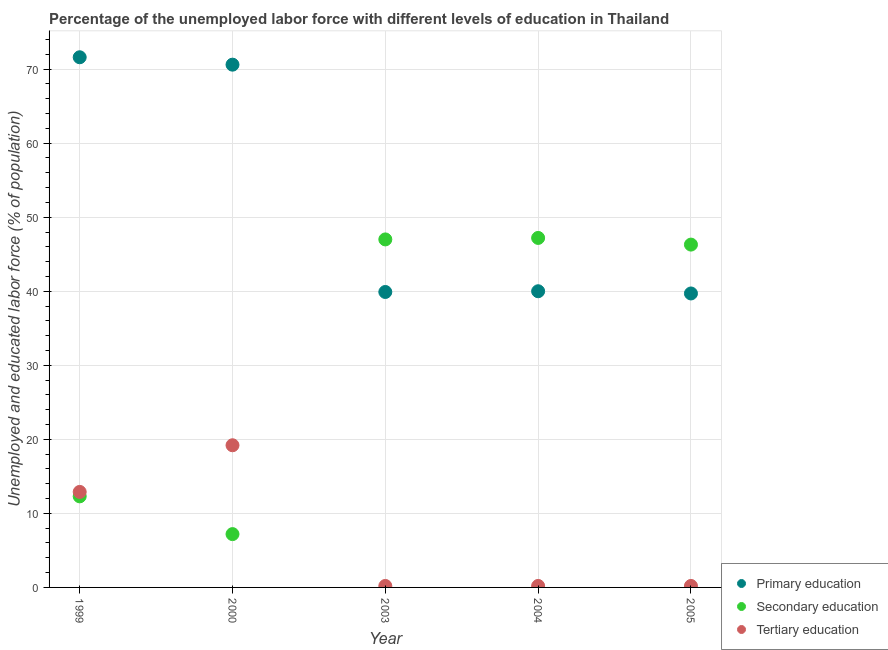How many different coloured dotlines are there?
Give a very brief answer. 3. What is the percentage of labor force who received primary education in 2005?
Offer a terse response. 39.7. Across all years, what is the maximum percentage of labor force who received secondary education?
Offer a terse response. 47.2. Across all years, what is the minimum percentage of labor force who received secondary education?
Keep it short and to the point. 7.2. What is the total percentage of labor force who received tertiary education in the graph?
Your response must be concise. 32.7. What is the difference between the percentage of labor force who received primary education in 2004 and that in 2005?
Your answer should be very brief. 0.3. What is the difference between the percentage of labor force who received secondary education in 2003 and the percentage of labor force who received tertiary education in 1999?
Your answer should be very brief. 34.1. What is the average percentage of labor force who received secondary education per year?
Provide a short and direct response. 32. In the year 2003, what is the difference between the percentage of labor force who received secondary education and percentage of labor force who received primary education?
Give a very brief answer. 7.1. In how many years, is the percentage of labor force who received secondary education greater than 58 %?
Ensure brevity in your answer.  0. What is the ratio of the percentage of labor force who received primary education in 1999 to that in 2005?
Offer a very short reply. 1.8. What is the difference between the highest and the second highest percentage of labor force who received tertiary education?
Provide a short and direct response. 6.3. What is the difference between the highest and the lowest percentage of labor force who received secondary education?
Your response must be concise. 40. In how many years, is the percentage of labor force who received tertiary education greater than the average percentage of labor force who received tertiary education taken over all years?
Your response must be concise. 2. Is the sum of the percentage of labor force who received primary education in 1999 and 2004 greater than the maximum percentage of labor force who received tertiary education across all years?
Offer a very short reply. Yes. Does the percentage of labor force who received secondary education monotonically increase over the years?
Provide a succinct answer. No. Is the percentage of labor force who received secondary education strictly greater than the percentage of labor force who received primary education over the years?
Ensure brevity in your answer.  No. How many years are there in the graph?
Give a very brief answer. 5. What is the difference between two consecutive major ticks on the Y-axis?
Offer a very short reply. 10. Does the graph contain any zero values?
Provide a succinct answer. No. Does the graph contain grids?
Provide a short and direct response. Yes. Where does the legend appear in the graph?
Make the answer very short. Bottom right. How are the legend labels stacked?
Provide a short and direct response. Vertical. What is the title of the graph?
Your answer should be very brief. Percentage of the unemployed labor force with different levels of education in Thailand. Does "Ages 15-64" appear as one of the legend labels in the graph?
Ensure brevity in your answer.  No. What is the label or title of the X-axis?
Make the answer very short. Year. What is the label or title of the Y-axis?
Give a very brief answer. Unemployed and educated labor force (% of population). What is the Unemployed and educated labor force (% of population) in Primary education in 1999?
Give a very brief answer. 71.6. What is the Unemployed and educated labor force (% of population) of Secondary education in 1999?
Keep it short and to the point. 12.3. What is the Unemployed and educated labor force (% of population) in Tertiary education in 1999?
Your response must be concise. 12.9. What is the Unemployed and educated labor force (% of population) in Primary education in 2000?
Provide a succinct answer. 70.6. What is the Unemployed and educated labor force (% of population) of Secondary education in 2000?
Offer a terse response. 7.2. What is the Unemployed and educated labor force (% of population) in Tertiary education in 2000?
Your answer should be compact. 19.2. What is the Unemployed and educated labor force (% of population) in Primary education in 2003?
Offer a terse response. 39.9. What is the Unemployed and educated labor force (% of population) in Tertiary education in 2003?
Offer a terse response. 0.2. What is the Unemployed and educated labor force (% of population) of Secondary education in 2004?
Provide a short and direct response. 47.2. What is the Unemployed and educated labor force (% of population) in Tertiary education in 2004?
Make the answer very short. 0.2. What is the Unemployed and educated labor force (% of population) in Primary education in 2005?
Ensure brevity in your answer.  39.7. What is the Unemployed and educated labor force (% of population) of Secondary education in 2005?
Ensure brevity in your answer.  46.3. What is the Unemployed and educated labor force (% of population) in Tertiary education in 2005?
Ensure brevity in your answer.  0.2. Across all years, what is the maximum Unemployed and educated labor force (% of population) in Primary education?
Make the answer very short. 71.6. Across all years, what is the maximum Unemployed and educated labor force (% of population) of Secondary education?
Your answer should be very brief. 47.2. Across all years, what is the maximum Unemployed and educated labor force (% of population) in Tertiary education?
Offer a very short reply. 19.2. Across all years, what is the minimum Unemployed and educated labor force (% of population) in Primary education?
Your answer should be very brief. 39.7. Across all years, what is the minimum Unemployed and educated labor force (% of population) of Secondary education?
Your answer should be compact. 7.2. Across all years, what is the minimum Unemployed and educated labor force (% of population) of Tertiary education?
Give a very brief answer. 0.2. What is the total Unemployed and educated labor force (% of population) in Primary education in the graph?
Your answer should be very brief. 261.8. What is the total Unemployed and educated labor force (% of population) of Secondary education in the graph?
Ensure brevity in your answer.  160. What is the total Unemployed and educated labor force (% of population) in Tertiary education in the graph?
Ensure brevity in your answer.  32.7. What is the difference between the Unemployed and educated labor force (% of population) in Primary education in 1999 and that in 2000?
Your response must be concise. 1. What is the difference between the Unemployed and educated labor force (% of population) of Primary education in 1999 and that in 2003?
Keep it short and to the point. 31.7. What is the difference between the Unemployed and educated labor force (% of population) in Secondary education in 1999 and that in 2003?
Your response must be concise. -34.7. What is the difference between the Unemployed and educated labor force (% of population) in Primary education in 1999 and that in 2004?
Offer a terse response. 31.6. What is the difference between the Unemployed and educated labor force (% of population) of Secondary education in 1999 and that in 2004?
Give a very brief answer. -34.9. What is the difference between the Unemployed and educated labor force (% of population) of Primary education in 1999 and that in 2005?
Give a very brief answer. 31.9. What is the difference between the Unemployed and educated labor force (% of population) in Secondary education in 1999 and that in 2005?
Your response must be concise. -34. What is the difference between the Unemployed and educated labor force (% of population) in Tertiary education in 1999 and that in 2005?
Your response must be concise. 12.7. What is the difference between the Unemployed and educated labor force (% of population) in Primary education in 2000 and that in 2003?
Provide a short and direct response. 30.7. What is the difference between the Unemployed and educated labor force (% of population) of Secondary education in 2000 and that in 2003?
Make the answer very short. -39.8. What is the difference between the Unemployed and educated labor force (% of population) in Tertiary education in 2000 and that in 2003?
Your response must be concise. 19. What is the difference between the Unemployed and educated labor force (% of population) of Primary education in 2000 and that in 2004?
Your answer should be very brief. 30.6. What is the difference between the Unemployed and educated labor force (% of population) of Tertiary education in 2000 and that in 2004?
Provide a short and direct response. 19. What is the difference between the Unemployed and educated labor force (% of population) of Primary education in 2000 and that in 2005?
Provide a succinct answer. 30.9. What is the difference between the Unemployed and educated labor force (% of population) in Secondary education in 2000 and that in 2005?
Your answer should be very brief. -39.1. What is the difference between the Unemployed and educated labor force (% of population) of Primary education in 2003 and that in 2004?
Make the answer very short. -0.1. What is the difference between the Unemployed and educated labor force (% of population) in Tertiary education in 2003 and that in 2004?
Keep it short and to the point. 0. What is the difference between the Unemployed and educated labor force (% of population) in Primary education in 2004 and that in 2005?
Provide a short and direct response. 0.3. What is the difference between the Unemployed and educated labor force (% of population) of Primary education in 1999 and the Unemployed and educated labor force (% of population) of Secondary education in 2000?
Keep it short and to the point. 64.4. What is the difference between the Unemployed and educated labor force (% of population) of Primary education in 1999 and the Unemployed and educated labor force (% of population) of Tertiary education in 2000?
Provide a short and direct response. 52.4. What is the difference between the Unemployed and educated labor force (% of population) of Secondary education in 1999 and the Unemployed and educated labor force (% of population) of Tertiary education in 2000?
Provide a short and direct response. -6.9. What is the difference between the Unemployed and educated labor force (% of population) of Primary education in 1999 and the Unemployed and educated labor force (% of population) of Secondary education in 2003?
Offer a terse response. 24.6. What is the difference between the Unemployed and educated labor force (% of population) of Primary education in 1999 and the Unemployed and educated labor force (% of population) of Tertiary education in 2003?
Make the answer very short. 71.4. What is the difference between the Unemployed and educated labor force (% of population) of Secondary education in 1999 and the Unemployed and educated labor force (% of population) of Tertiary education in 2003?
Ensure brevity in your answer.  12.1. What is the difference between the Unemployed and educated labor force (% of population) of Primary education in 1999 and the Unemployed and educated labor force (% of population) of Secondary education in 2004?
Provide a succinct answer. 24.4. What is the difference between the Unemployed and educated labor force (% of population) in Primary education in 1999 and the Unemployed and educated labor force (% of population) in Tertiary education in 2004?
Make the answer very short. 71.4. What is the difference between the Unemployed and educated labor force (% of population) in Primary education in 1999 and the Unemployed and educated labor force (% of population) in Secondary education in 2005?
Provide a succinct answer. 25.3. What is the difference between the Unemployed and educated labor force (% of population) in Primary education in 1999 and the Unemployed and educated labor force (% of population) in Tertiary education in 2005?
Your answer should be compact. 71.4. What is the difference between the Unemployed and educated labor force (% of population) in Primary education in 2000 and the Unemployed and educated labor force (% of population) in Secondary education in 2003?
Provide a short and direct response. 23.6. What is the difference between the Unemployed and educated labor force (% of population) of Primary education in 2000 and the Unemployed and educated labor force (% of population) of Tertiary education in 2003?
Provide a succinct answer. 70.4. What is the difference between the Unemployed and educated labor force (% of population) of Primary education in 2000 and the Unemployed and educated labor force (% of population) of Secondary education in 2004?
Make the answer very short. 23.4. What is the difference between the Unemployed and educated labor force (% of population) of Primary education in 2000 and the Unemployed and educated labor force (% of population) of Tertiary education in 2004?
Ensure brevity in your answer.  70.4. What is the difference between the Unemployed and educated labor force (% of population) of Primary education in 2000 and the Unemployed and educated labor force (% of population) of Secondary education in 2005?
Provide a short and direct response. 24.3. What is the difference between the Unemployed and educated labor force (% of population) in Primary education in 2000 and the Unemployed and educated labor force (% of population) in Tertiary education in 2005?
Offer a terse response. 70.4. What is the difference between the Unemployed and educated labor force (% of population) of Primary education in 2003 and the Unemployed and educated labor force (% of population) of Secondary education in 2004?
Make the answer very short. -7.3. What is the difference between the Unemployed and educated labor force (% of population) in Primary education in 2003 and the Unemployed and educated labor force (% of population) in Tertiary education in 2004?
Offer a terse response. 39.7. What is the difference between the Unemployed and educated labor force (% of population) of Secondary education in 2003 and the Unemployed and educated labor force (% of population) of Tertiary education in 2004?
Make the answer very short. 46.8. What is the difference between the Unemployed and educated labor force (% of population) in Primary education in 2003 and the Unemployed and educated labor force (% of population) in Secondary education in 2005?
Your answer should be very brief. -6.4. What is the difference between the Unemployed and educated labor force (% of population) in Primary education in 2003 and the Unemployed and educated labor force (% of population) in Tertiary education in 2005?
Offer a very short reply. 39.7. What is the difference between the Unemployed and educated labor force (% of population) of Secondary education in 2003 and the Unemployed and educated labor force (% of population) of Tertiary education in 2005?
Offer a terse response. 46.8. What is the difference between the Unemployed and educated labor force (% of population) in Primary education in 2004 and the Unemployed and educated labor force (% of population) in Secondary education in 2005?
Your response must be concise. -6.3. What is the difference between the Unemployed and educated labor force (% of population) in Primary education in 2004 and the Unemployed and educated labor force (% of population) in Tertiary education in 2005?
Ensure brevity in your answer.  39.8. What is the difference between the Unemployed and educated labor force (% of population) in Secondary education in 2004 and the Unemployed and educated labor force (% of population) in Tertiary education in 2005?
Your response must be concise. 47. What is the average Unemployed and educated labor force (% of population) of Primary education per year?
Offer a very short reply. 52.36. What is the average Unemployed and educated labor force (% of population) in Tertiary education per year?
Offer a terse response. 6.54. In the year 1999, what is the difference between the Unemployed and educated labor force (% of population) in Primary education and Unemployed and educated labor force (% of population) in Secondary education?
Provide a succinct answer. 59.3. In the year 1999, what is the difference between the Unemployed and educated labor force (% of population) of Primary education and Unemployed and educated labor force (% of population) of Tertiary education?
Keep it short and to the point. 58.7. In the year 1999, what is the difference between the Unemployed and educated labor force (% of population) in Secondary education and Unemployed and educated labor force (% of population) in Tertiary education?
Make the answer very short. -0.6. In the year 2000, what is the difference between the Unemployed and educated labor force (% of population) of Primary education and Unemployed and educated labor force (% of population) of Secondary education?
Your response must be concise. 63.4. In the year 2000, what is the difference between the Unemployed and educated labor force (% of population) of Primary education and Unemployed and educated labor force (% of population) of Tertiary education?
Offer a very short reply. 51.4. In the year 2000, what is the difference between the Unemployed and educated labor force (% of population) in Secondary education and Unemployed and educated labor force (% of population) in Tertiary education?
Provide a short and direct response. -12. In the year 2003, what is the difference between the Unemployed and educated labor force (% of population) of Primary education and Unemployed and educated labor force (% of population) of Tertiary education?
Ensure brevity in your answer.  39.7. In the year 2003, what is the difference between the Unemployed and educated labor force (% of population) of Secondary education and Unemployed and educated labor force (% of population) of Tertiary education?
Your answer should be compact. 46.8. In the year 2004, what is the difference between the Unemployed and educated labor force (% of population) of Primary education and Unemployed and educated labor force (% of population) of Tertiary education?
Offer a very short reply. 39.8. In the year 2004, what is the difference between the Unemployed and educated labor force (% of population) of Secondary education and Unemployed and educated labor force (% of population) of Tertiary education?
Keep it short and to the point. 47. In the year 2005, what is the difference between the Unemployed and educated labor force (% of population) of Primary education and Unemployed and educated labor force (% of population) of Secondary education?
Provide a succinct answer. -6.6. In the year 2005, what is the difference between the Unemployed and educated labor force (% of population) in Primary education and Unemployed and educated labor force (% of population) in Tertiary education?
Your response must be concise. 39.5. In the year 2005, what is the difference between the Unemployed and educated labor force (% of population) of Secondary education and Unemployed and educated labor force (% of population) of Tertiary education?
Offer a terse response. 46.1. What is the ratio of the Unemployed and educated labor force (% of population) in Primary education in 1999 to that in 2000?
Your answer should be very brief. 1.01. What is the ratio of the Unemployed and educated labor force (% of population) of Secondary education in 1999 to that in 2000?
Give a very brief answer. 1.71. What is the ratio of the Unemployed and educated labor force (% of population) of Tertiary education in 1999 to that in 2000?
Offer a very short reply. 0.67. What is the ratio of the Unemployed and educated labor force (% of population) of Primary education in 1999 to that in 2003?
Provide a short and direct response. 1.79. What is the ratio of the Unemployed and educated labor force (% of population) of Secondary education in 1999 to that in 2003?
Make the answer very short. 0.26. What is the ratio of the Unemployed and educated labor force (% of population) in Tertiary education in 1999 to that in 2003?
Offer a very short reply. 64.5. What is the ratio of the Unemployed and educated labor force (% of population) of Primary education in 1999 to that in 2004?
Keep it short and to the point. 1.79. What is the ratio of the Unemployed and educated labor force (% of population) in Secondary education in 1999 to that in 2004?
Provide a succinct answer. 0.26. What is the ratio of the Unemployed and educated labor force (% of population) in Tertiary education in 1999 to that in 2004?
Offer a terse response. 64.5. What is the ratio of the Unemployed and educated labor force (% of population) of Primary education in 1999 to that in 2005?
Ensure brevity in your answer.  1.8. What is the ratio of the Unemployed and educated labor force (% of population) in Secondary education in 1999 to that in 2005?
Make the answer very short. 0.27. What is the ratio of the Unemployed and educated labor force (% of population) in Tertiary education in 1999 to that in 2005?
Ensure brevity in your answer.  64.5. What is the ratio of the Unemployed and educated labor force (% of population) of Primary education in 2000 to that in 2003?
Give a very brief answer. 1.77. What is the ratio of the Unemployed and educated labor force (% of population) in Secondary education in 2000 to that in 2003?
Offer a terse response. 0.15. What is the ratio of the Unemployed and educated labor force (% of population) of Tertiary education in 2000 to that in 2003?
Make the answer very short. 96. What is the ratio of the Unemployed and educated labor force (% of population) of Primary education in 2000 to that in 2004?
Offer a very short reply. 1.76. What is the ratio of the Unemployed and educated labor force (% of population) in Secondary education in 2000 to that in 2004?
Your answer should be compact. 0.15. What is the ratio of the Unemployed and educated labor force (% of population) in Tertiary education in 2000 to that in 2004?
Provide a short and direct response. 96. What is the ratio of the Unemployed and educated labor force (% of population) in Primary education in 2000 to that in 2005?
Provide a succinct answer. 1.78. What is the ratio of the Unemployed and educated labor force (% of population) of Secondary education in 2000 to that in 2005?
Ensure brevity in your answer.  0.16. What is the ratio of the Unemployed and educated labor force (% of population) of Tertiary education in 2000 to that in 2005?
Offer a terse response. 96. What is the ratio of the Unemployed and educated labor force (% of population) of Primary education in 2003 to that in 2004?
Your answer should be very brief. 1. What is the ratio of the Unemployed and educated labor force (% of population) in Secondary education in 2003 to that in 2004?
Offer a terse response. 1. What is the ratio of the Unemployed and educated labor force (% of population) in Secondary education in 2003 to that in 2005?
Give a very brief answer. 1.02. What is the ratio of the Unemployed and educated labor force (% of population) in Tertiary education in 2003 to that in 2005?
Your answer should be very brief. 1. What is the ratio of the Unemployed and educated labor force (% of population) in Primary education in 2004 to that in 2005?
Your answer should be very brief. 1.01. What is the ratio of the Unemployed and educated labor force (% of population) of Secondary education in 2004 to that in 2005?
Provide a short and direct response. 1.02. What is the difference between the highest and the second highest Unemployed and educated labor force (% of population) in Primary education?
Keep it short and to the point. 1. What is the difference between the highest and the second highest Unemployed and educated labor force (% of population) of Tertiary education?
Provide a short and direct response. 6.3. What is the difference between the highest and the lowest Unemployed and educated labor force (% of population) in Primary education?
Keep it short and to the point. 31.9. What is the difference between the highest and the lowest Unemployed and educated labor force (% of population) of Tertiary education?
Provide a succinct answer. 19. 